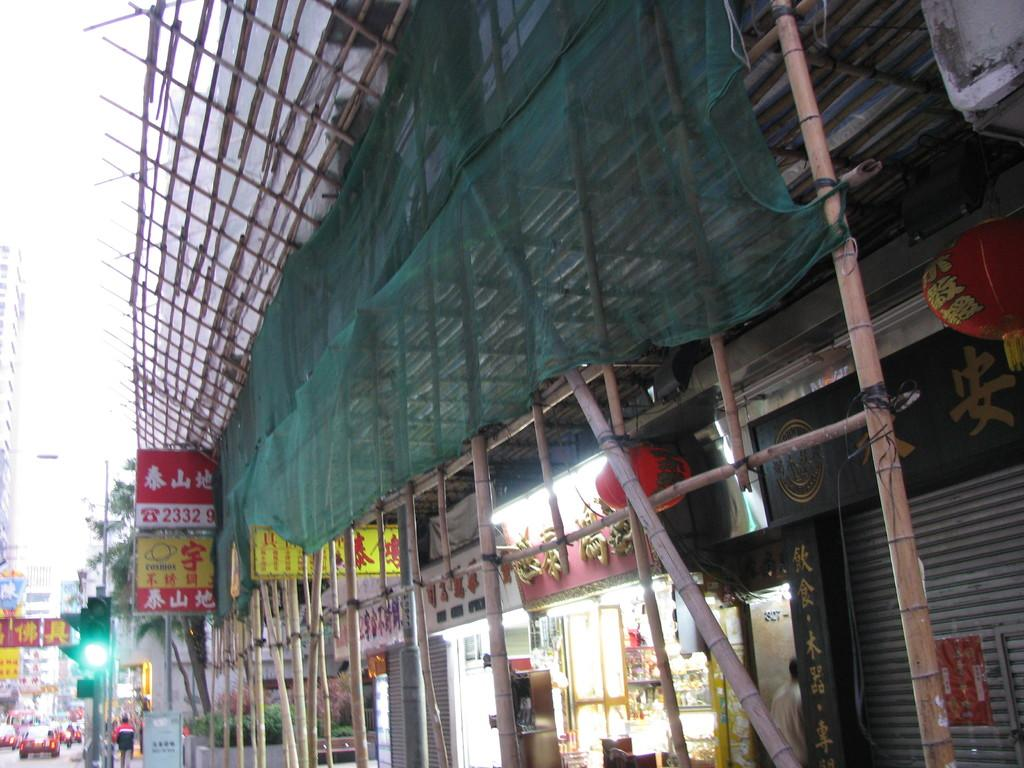What can be seen on the road in the image? There are vehicles on the road in the image. What type of structures are present in the image? There are buildings in the image. What objects are visible in the image that might be used for displaying information or advertisements? There are boards in the image. What type of lighting is present in the image? There are lights in the image. What type of decorative lighting can be seen in the image? There are paper lanterns in the image. What type of vegetation is present in the image? There are plants and trees in the image. What type of vertical structures are present in the image? There are wooden poles in the image. What part of the natural environment is visible in the image? The sky is visible in the image. Where is the lunchroom located in the image? There is no mention of a lunchroom in the image. What type of wood is used to construct the buildings in the image? The image does not provide information about the type of wood used in the construction of the buildings. 